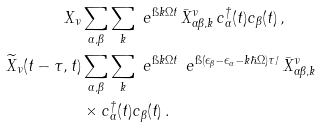Convert formula to latex. <formula><loc_0><loc_0><loc_500><loc_500>X _ { \nu } & \sum _ { \alpha , \beta } \sum _ { k } \ e ^ { \i k \Omega t } \, \bar { X } ^ { \nu } _ { \alpha \beta , k } \, c ^ { \dagger } _ { \alpha } ( t ) c _ { \beta } ( t ) \, , \\ \widetilde { X } _ { \nu } ( t - \tau , t ) & \sum _ { \alpha , \beta } \sum _ { k } \ e ^ { \i k \Omega t } \, \ e ^ { \i ( \epsilon _ { \beta } - \epsilon _ { \alpha } - k \hbar { \Omega } ) \tau / } \, \bar { X } ^ { \nu } _ { \alpha \beta , k } \\ & \times c ^ { \dagger } _ { \alpha } ( t ) c _ { \beta } ( t ) \, .</formula> 